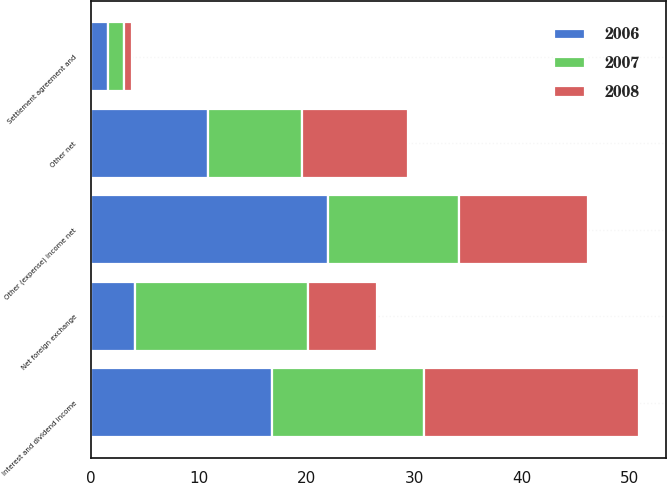Convert chart. <chart><loc_0><loc_0><loc_500><loc_500><stacked_bar_chart><ecel><fcel>Interest and dividend income<fcel>Net foreign exchange<fcel>Settlement agreement and<fcel>Other net<fcel>Other (expense) income net<nl><fcel>2007<fcel>14.1<fcel>16<fcel>1.5<fcel>8.7<fcel>12.1<nl><fcel>2008<fcel>19.9<fcel>6.4<fcel>0.7<fcel>9.8<fcel>12<nl><fcel>2006<fcel>16.8<fcel>4.1<fcel>1.6<fcel>10.9<fcel>22<nl></chart> 